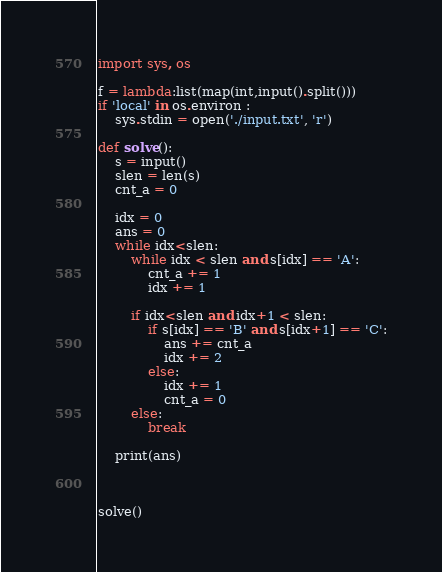<code> <loc_0><loc_0><loc_500><loc_500><_Python_>import sys, os

f = lambda:list(map(int,input().split()))
if 'local' in os.environ :
    sys.stdin = open('./input.txt', 'r')

def solve():
    s = input()
    slen = len(s)
    cnt_a = 0

    idx = 0
    ans = 0
    while idx<slen:
        while idx < slen and s[idx] == 'A':
            cnt_a += 1
            idx += 1
        
        if idx<slen and idx+1 < slen:
            if s[idx] == 'B' and s[idx+1] == 'C':
                ans += cnt_a
                idx += 2
            else:
                idx += 1
                cnt_a = 0
        else:
            break
    
    print(ans)



solve()
</code> 